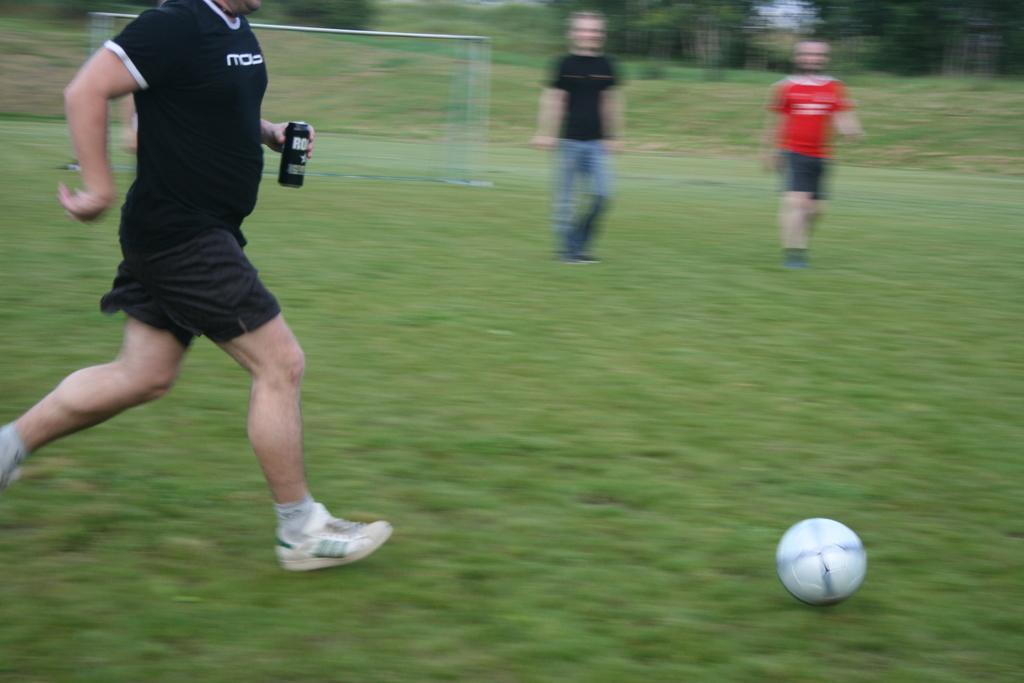Please provide a concise description of this image. There is a person standing and holding bottle and we can see ball on the grass. On the background we can see trees and sky. 